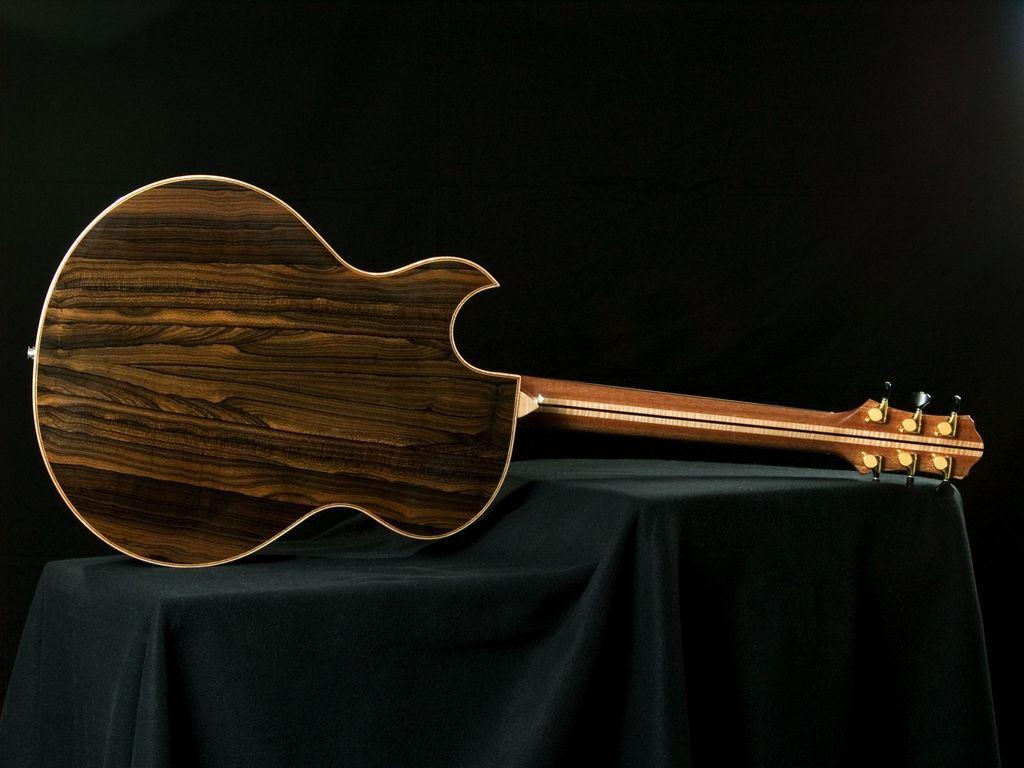What type of musical instrument is in the image? There is a brown guitar in the image. Where is the guitar located? The guitar is placed on a table. What color is the cloth on the table? The cloth on the table is green. How many pets can be seen playing with the guitar in the image? There are no pets present in the image, and the guitar is not being played with. 